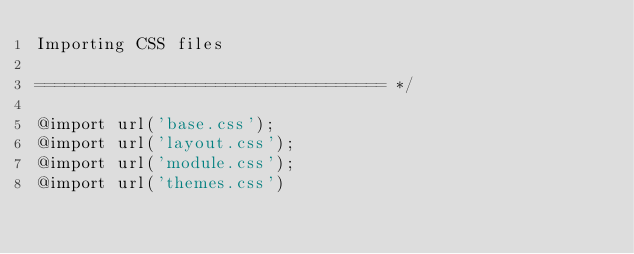<code> <loc_0><loc_0><loc_500><loc_500><_CSS_>Importing CSS files

=================================== */

@import url('base.css');
@import url('layout.css');
@import url('module.css');
@import url('themes.css')
</code> 